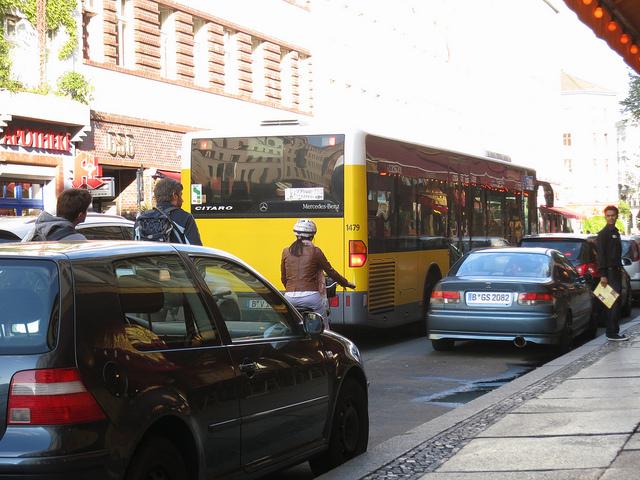How many cars can be seen? After closely examining the image, I can confirm that there is one car visible, parked on the right side of the street, behind the cyclists. The yellow vehicle in the center is a bus, distinguishing it from typical cars due to its larger size and design meant to carry multiple passengers. 